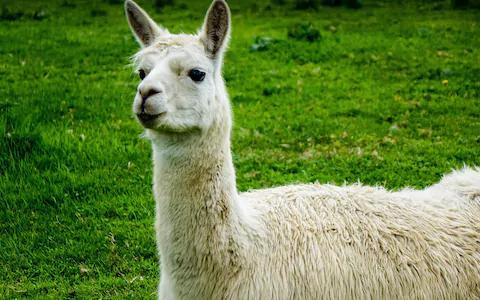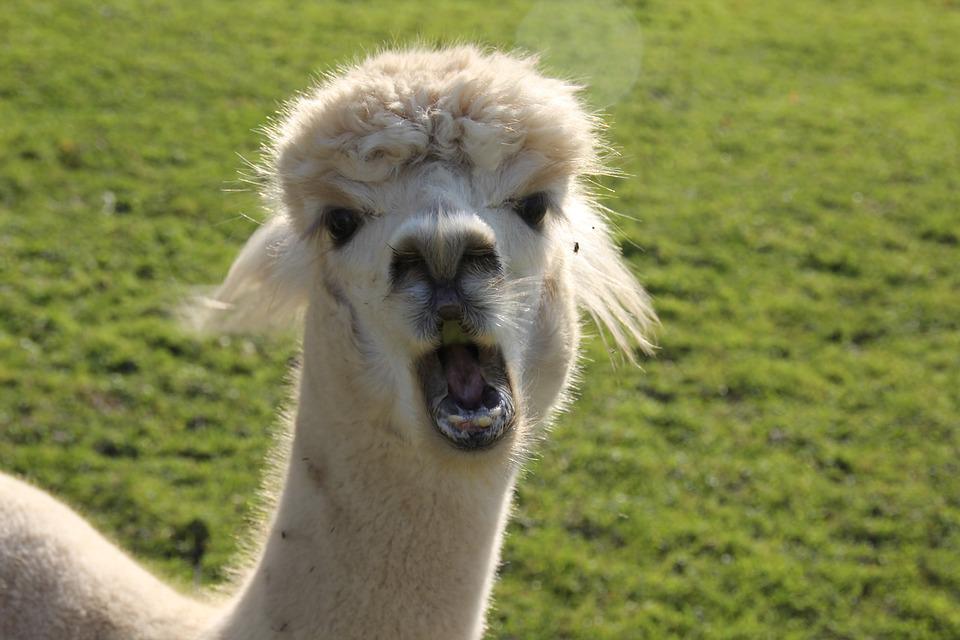The first image is the image on the left, the second image is the image on the right. Examine the images to the left and right. Is the description "There are three mammals in total." accurate? Answer yes or no. No. The first image is the image on the left, the second image is the image on the right. For the images shown, is this caption "At least one llama has food in its mouth." true? Answer yes or no. No. 